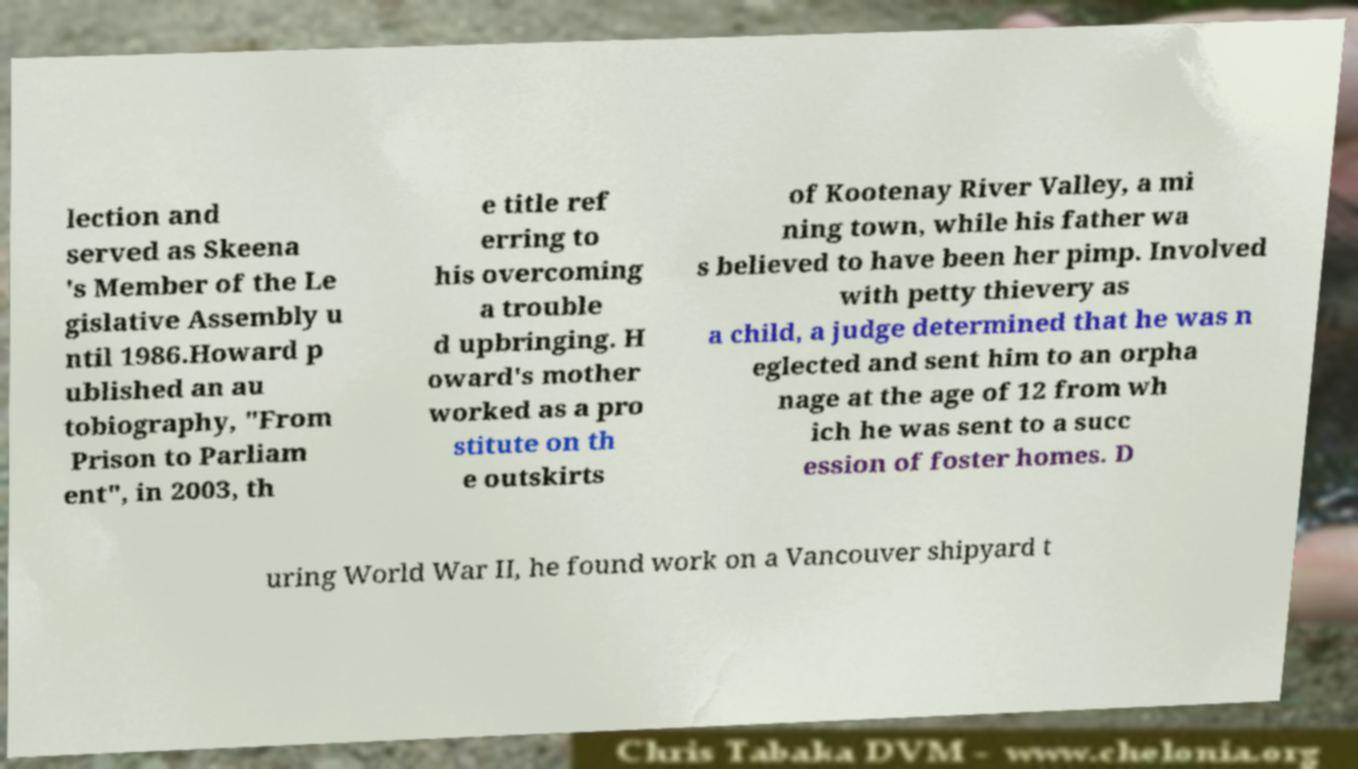What messages or text are displayed in this image? I need them in a readable, typed format. lection and served as Skeena 's Member of the Le gislative Assembly u ntil 1986.Howard p ublished an au tobiography, "From Prison to Parliam ent", in 2003, th e title ref erring to his overcoming a trouble d upbringing. H oward's mother worked as a pro stitute on th e outskirts of Kootenay River Valley, a mi ning town, while his father wa s believed to have been her pimp. Involved with petty thievery as a child, a judge determined that he was n eglected and sent him to an orpha nage at the age of 12 from wh ich he was sent to a succ ession of foster homes. D uring World War II, he found work on a Vancouver shipyard t 